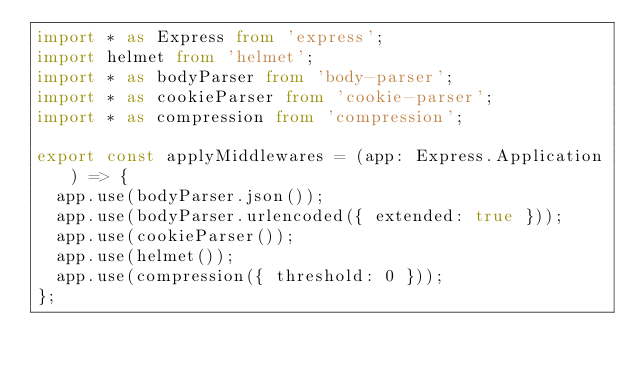<code> <loc_0><loc_0><loc_500><loc_500><_TypeScript_>import * as Express from 'express';
import helmet from 'helmet';
import * as bodyParser from 'body-parser';
import * as cookieParser from 'cookie-parser';
import * as compression from 'compression';

export const applyMiddlewares = (app: Express.Application) => {
  app.use(bodyParser.json());
  app.use(bodyParser.urlencoded({ extended: true }));
  app.use(cookieParser());
  app.use(helmet());
  app.use(compression({ threshold: 0 }));
};
</code> 